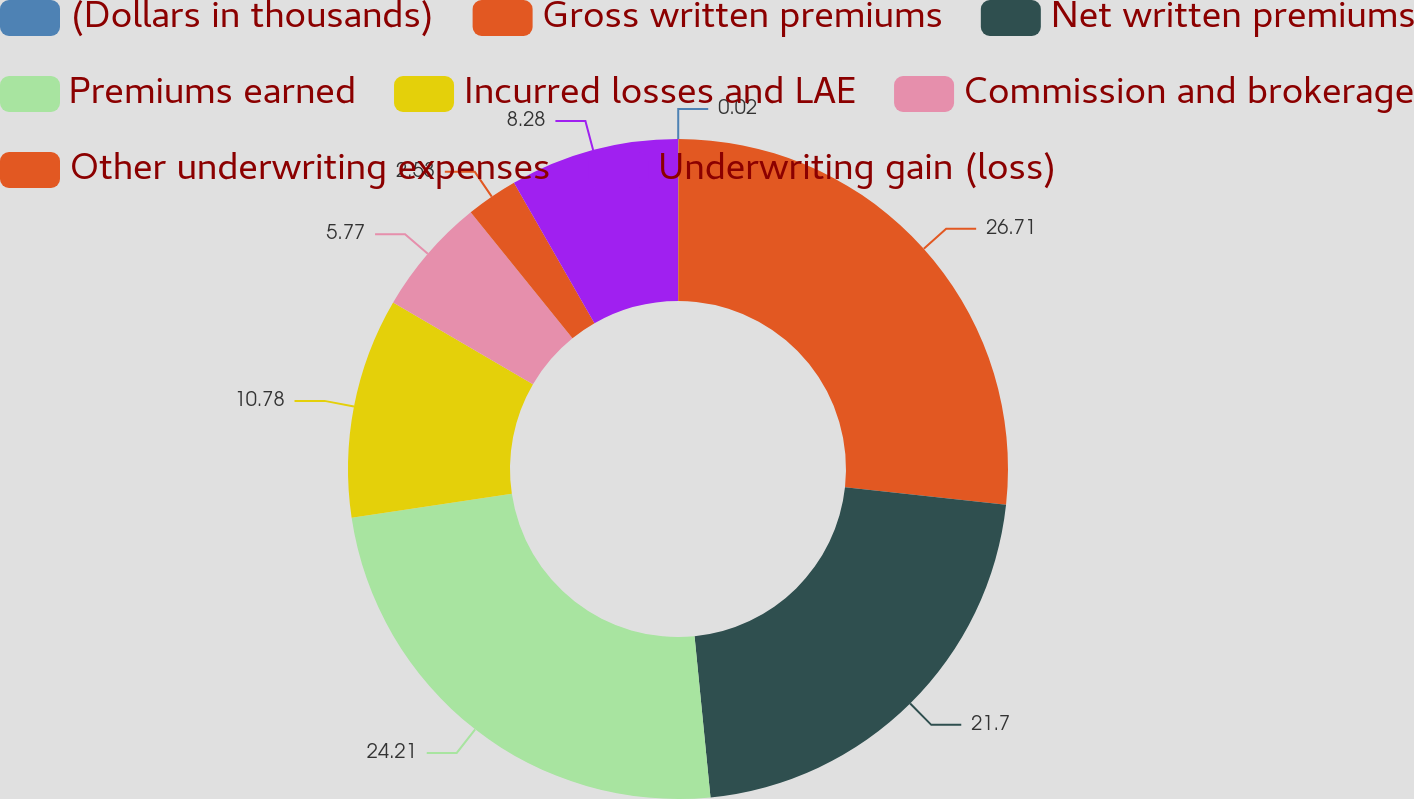Convert chart to OTSL. <chart><loc_0><loc_0><loc_500><loc_500><pie_chart><fcel>(Dollars in thousands)<fcel>Gross written premiums<fcel>Net written premiums<fcel>Premiums earned<fcel>Incurred losses and LAE<fcel>Commission and brokerage<fcel>Other underwriting expenses<fcel>Underwriting gain (loss)<nl><fcel>0.02%<fcel>26.71%<fcel>21.7%<fcel>24.21%<fcel>10.78%<fcel>5.77%<fcel>2.53%<fcel>8.28%<nl></chart> 